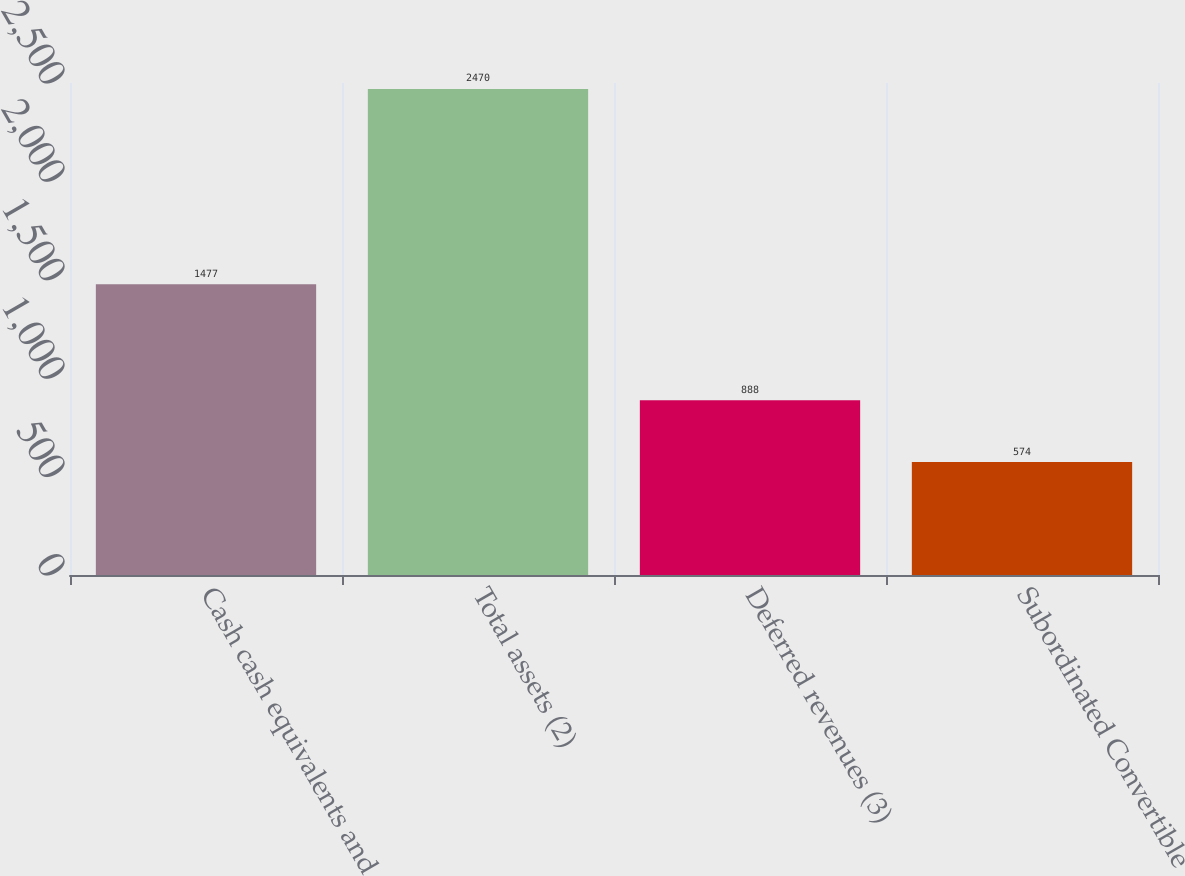Convert chart. <chart><loc_0><loc_0><loc_500><loc_500><bar_chart><fcel>Cash cash equivalents and<fcel>Total assets (2)<fcel>Deferred revenues (3)<fcel>Subordinated Convertible<nl><fcel>1477<fcel>2470<fcel>888<fcel>574<nl></chart> 